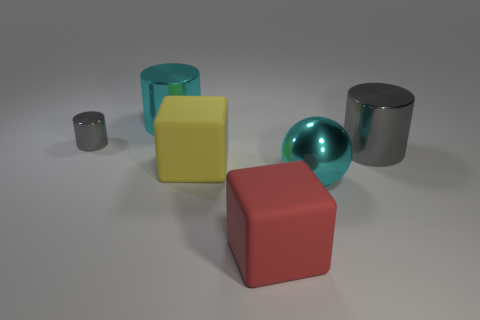Subtract all cyan blocks. Subtract all yellow cylinders. How many blocks are left? 2 Add 3 yellow shiny cylinders. How many objects exist? 9 Subtract all cubes. How many objects are left? 4 Subtract 0 brown balls. How many objects are left? 6 Subtract all shiny things. Subtract all large cyan metallic things. How many objects are left? 0 Add 3 large blocks. How many large blocks are left? 5 Add 1 cylinders. How many cylinders exist? 4 